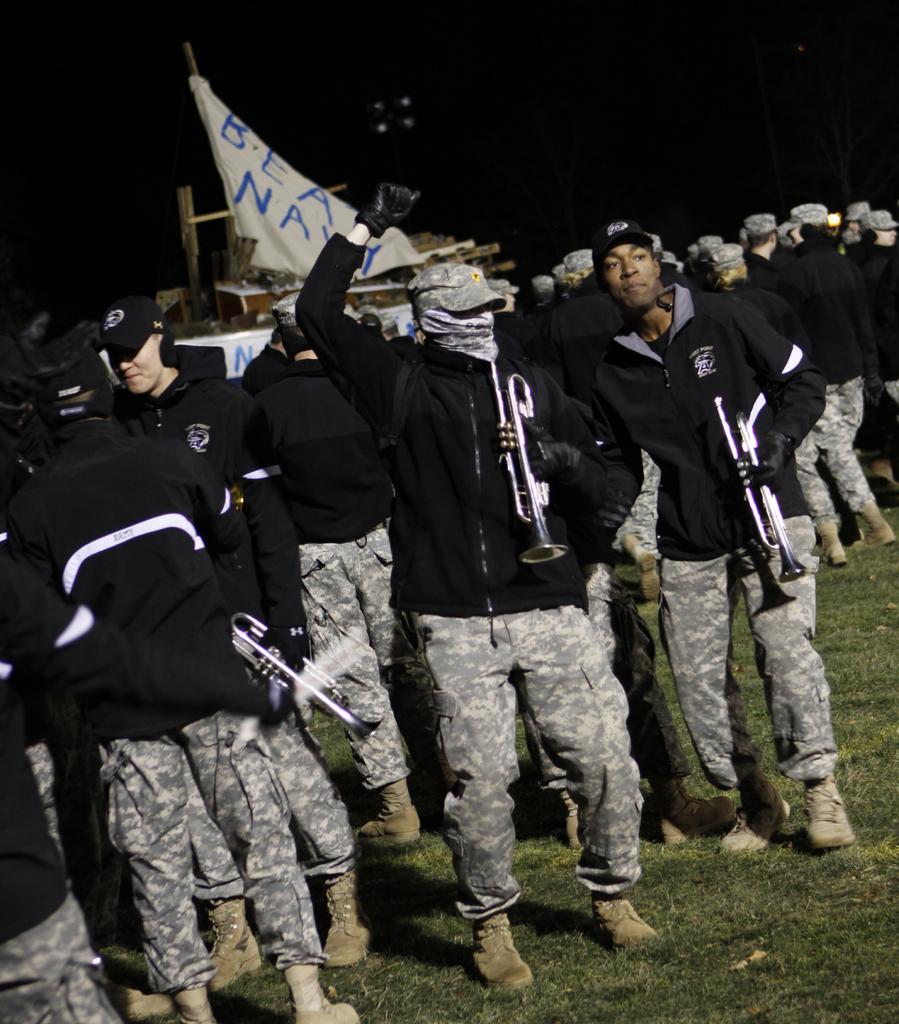How would you summarize this image in a sentence or two? In this image I can see number of people are standing. I can see all of them are wearing uniforms, shoes, black colour jackets and caps. I can also see few of them are holding musical instruments and in the background I can see a white colour thing and on it I can see something is written. I can also see grass and I can see this image is little bit in dark from background. 